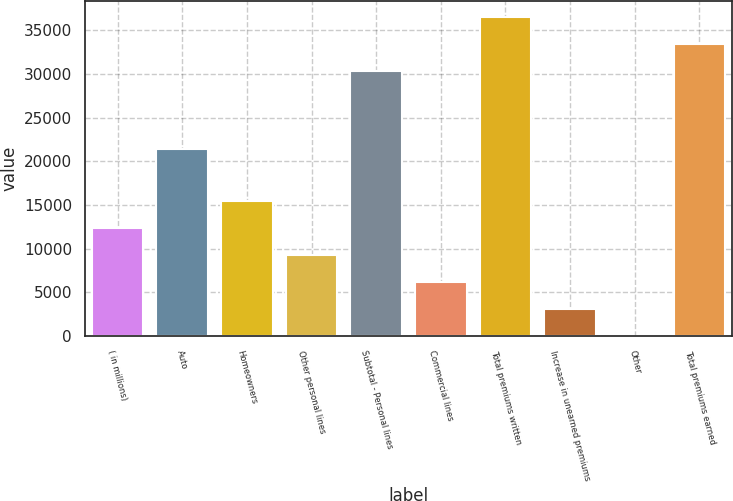Convert chart to OTSL. <chart><loc_0><loc_0><loc_500><loc_500><bar_chart><fcel>( in millions)<fcel>Auto<fcel>Homeowners<fcel>Other personal lines<fcel>Subtotal - Personal lines<fcel>Commercial lines<fcel>Total premiums written<fcel>Increase in unearned premiums<fcel>Other<fcel>Total premiums earned<nl><fcel>12367.2<fcel>21425<fcel>15454<fcel>9280.4<fcel>30389<fcel>6193.6<fcel>36562.6<fcel>3106.8<fcel>20<fcel>33475.8<nl></chart> 